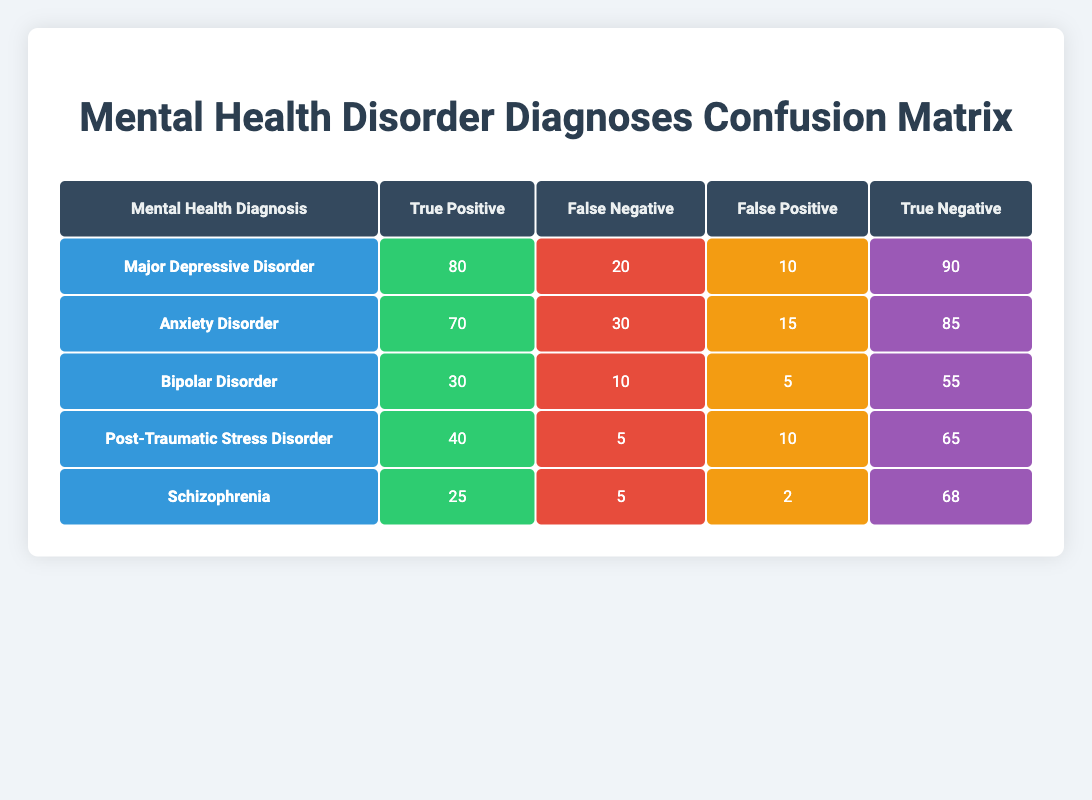What is the true positive value for Major Depressive Disorder? The true positive value for Major Depressive Disorder is listed in the table under the corresponding column, which shows that it is 80.
Answer: 80 What is the false negative value for Anxiety Disorder? The false negative value for Anxiety Disorder is indicated in the table, specifying that it is 30.
Answer: 30 How many false positives are there in total across all diagnoses? To find the total false positives, we sum the values from each disorder's false positive column: (10 + 15 + 5 + 10 + 2) = 52.
Answer: 52 Is the true negative value for Schizophrenia greater than the total of true positives for all disorders? The true negative value for Schizophrenia is 68. The total true positives are: (80 + 70 + 30 + 40 + 25) = 245. Since 68 is not greater than 245, the answer is no.
Answer: No What is the ratio of true positives to false negatives for Post-Traumatic Stress Disorder? For Post-Traumatic Stress Disorder, the true positive value is 40 and the false negative value is 5. The ratio is calculated by dividing the two: 40 / 5 = 8.
Answer: 8 What is the total number of referrals (true positives and false negatives) for Bipolar Disorder? The total number of referrals for Bipolar Disorder is calculated by adding true positives and false negatives: 30 + 10 = 40.
Answer: 40 Which mental health diagnosis has the highest number of true positive cases? By examining the true positive values for all disorders, Major Depressive Disorder has the highest at 80.
Answer: Major Depressive Disorder Are there more false negatives for Anxiety Disorder than for Bipolar Disorder? Anxiety Disorder has a false negative value of 30, while Bipolar Disorder has 10. Since 30 is more than 10, the answer is yes.
Answer: Yes What is the average number of true negatives across all diagnoses? The true negatives are 90, 85, 55, 65, and 68. The sum is 90 + 85 + 55 + 65 + 68 = 363. The average is 363 / 5 = 72.6.
Answer: 72.6 